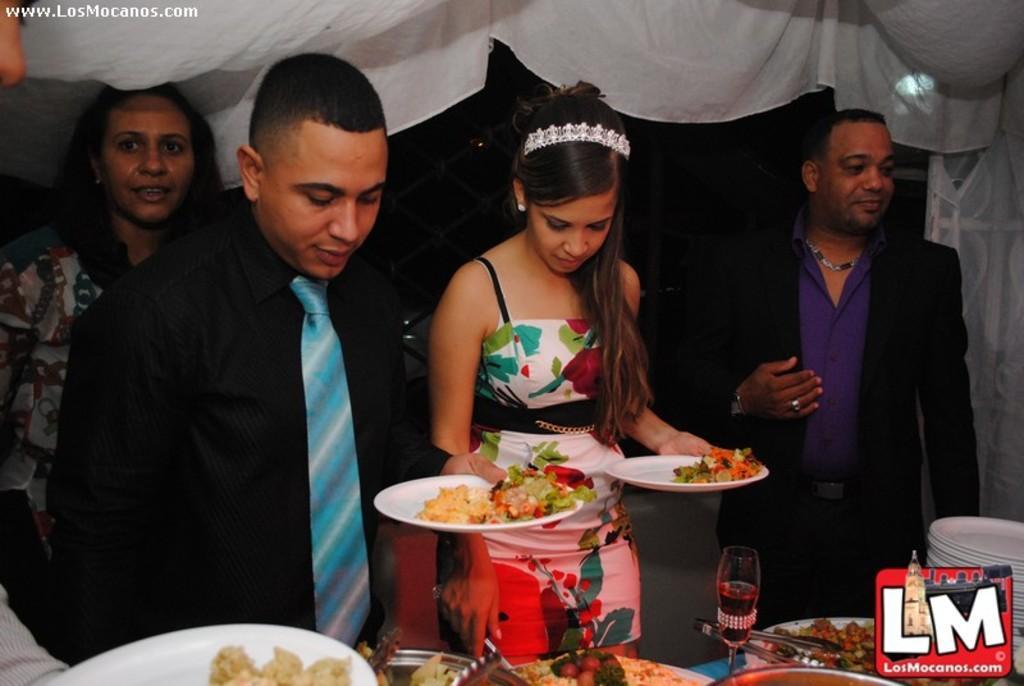Please provide a concise description of this image. In this image we can see people standing and holding plates. At the bottom there is a table and we can see plates, glass, spatula and some food placed on the table. In the background there is a curtain and we can see a light. 